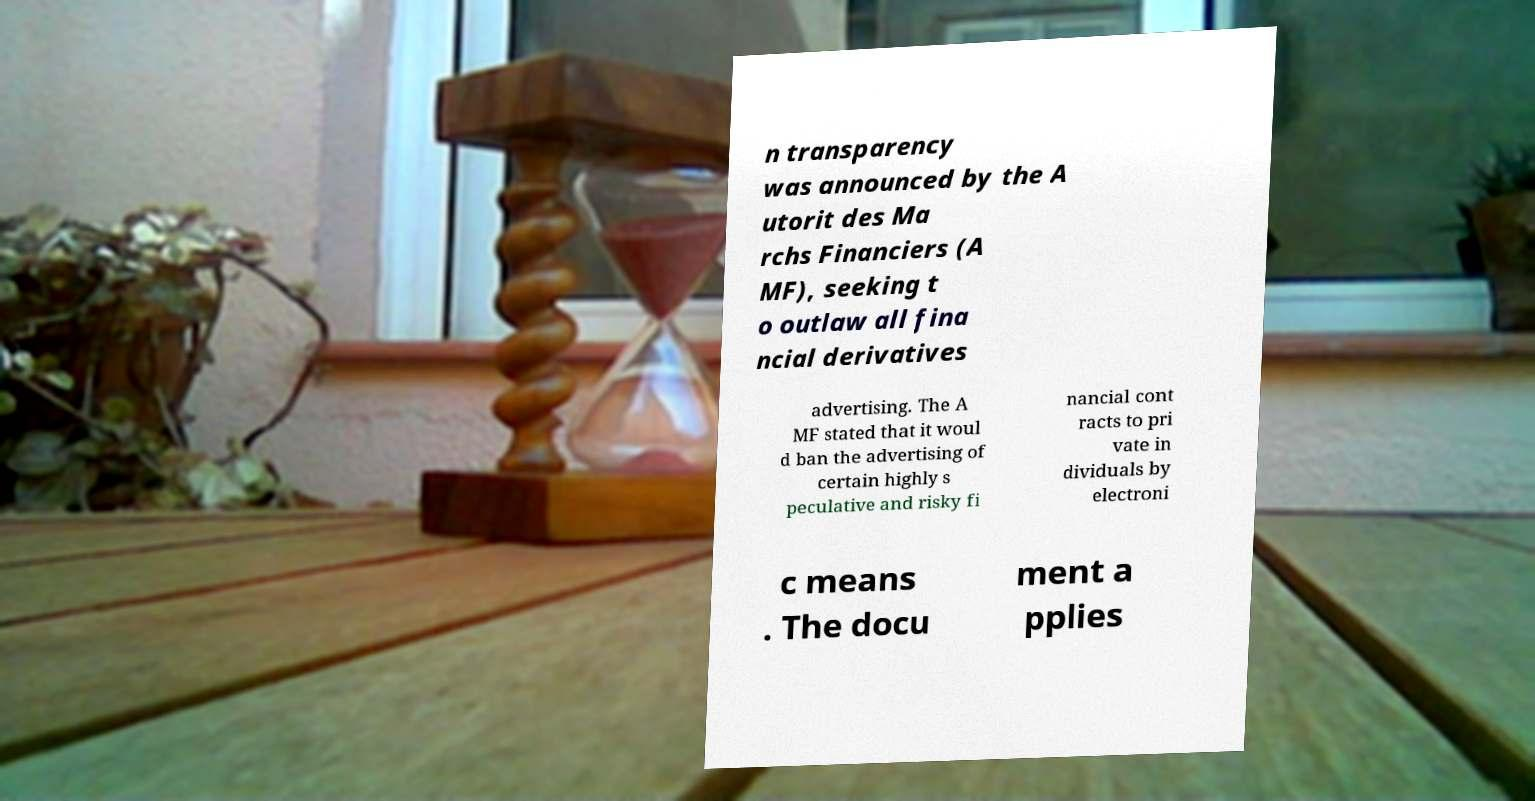Could you extract and type out the text from this image? n transparency was announced by the A utorit des Ma rchs Financiers (A MF), seeking t o outlaw all fina ncial derivatives advertising. The A MF stated that it woul d ban the advertising of certain highly s peculative and risky fi nancial cont racts to pri vate in dividuals by electroni c means . The docu ment a pplies 